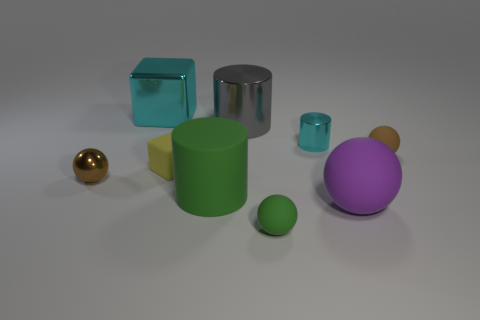Subtract all rubber balls. How many balls are left? 1 Subtract 3 balls. How many balls are left? 1 Subtract all spheres. How many objects are left? 5 Subtract all green balls. How many purple cubes are left? 0 Subtract all gray cylinders. How many cylinders are left? 2 Subtract all purple cylinders. Subtract all blue blocks. How many cylinders are left? 3 Add 6 tiny brown things. How many tiny brown things exist? 8 Subtract 0 purple cylinders. How many objects are left? 9 Subtract all cyan cylinders. Subtract all large metal cubes. How many objects are left? 7 Add 2 big shiny objects. How many big shiny objects are left? 4 